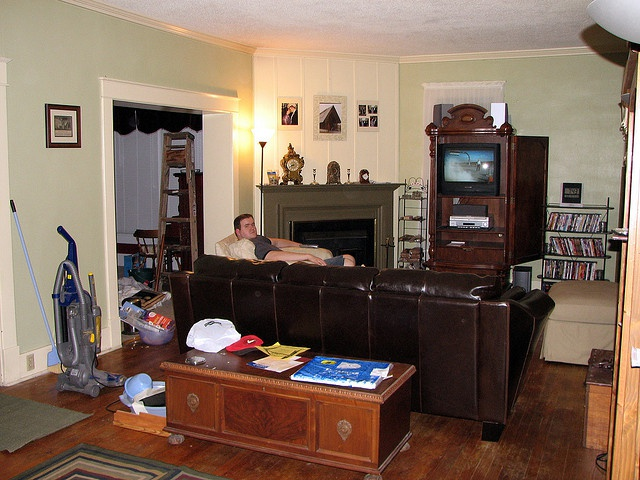Describe the objects in this image and their specific colors. I can see couch in tan, black, maroon, and gray tones, tv in tan, black, gray, and darkgray tones, book in tan, blue, white, and lightblue tones, people in tan, brown, black, maroon, and salmon tones, and chair in tan and gray tones in this image. 